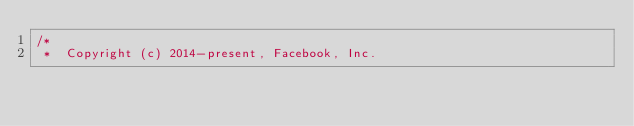Convert code to text. <code><loc_0><loc_0><loc_500><loc_500><_ObjectiveC_>/*
 *  Copyright (c) 2014-present, Facebook, Inc.</code> 